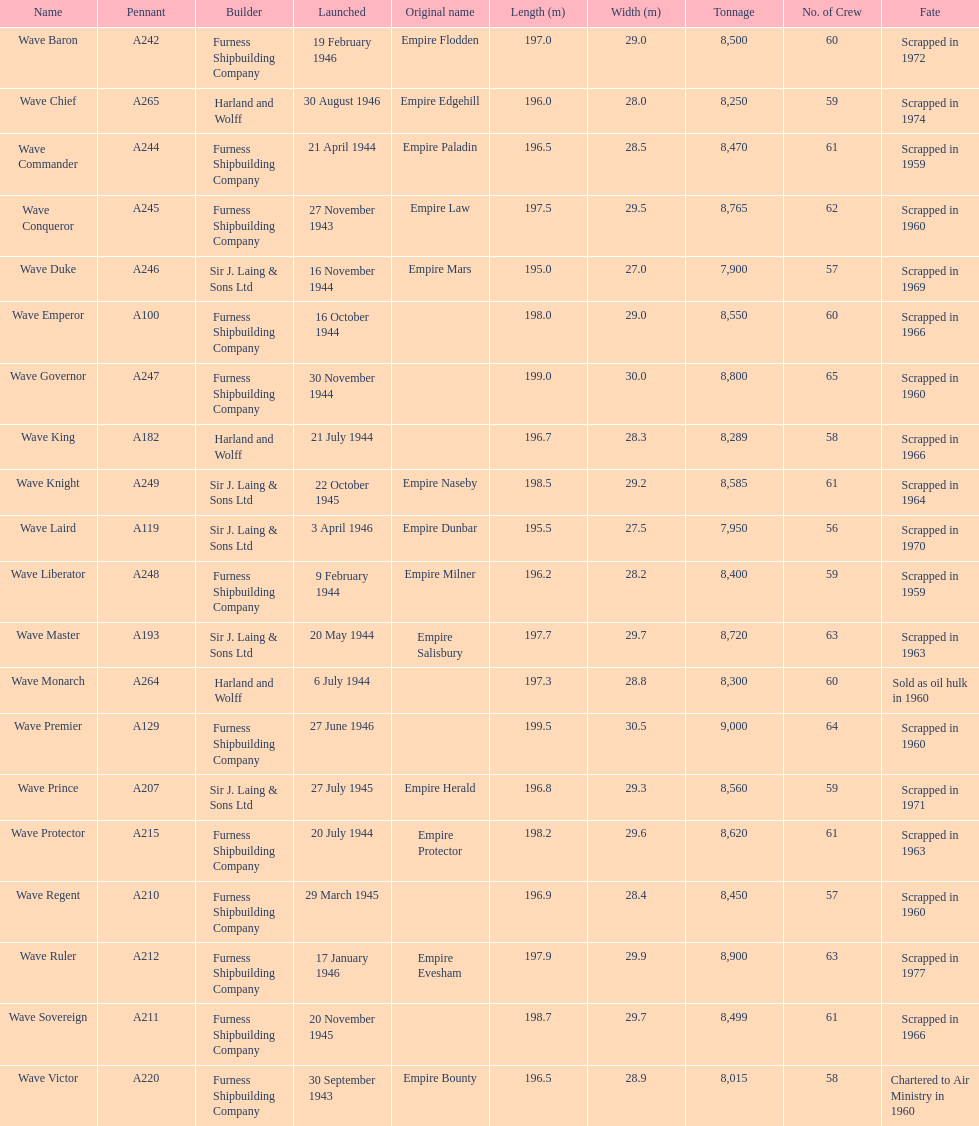What is the name of the last ship that was scrapped? Wave Ruler. 